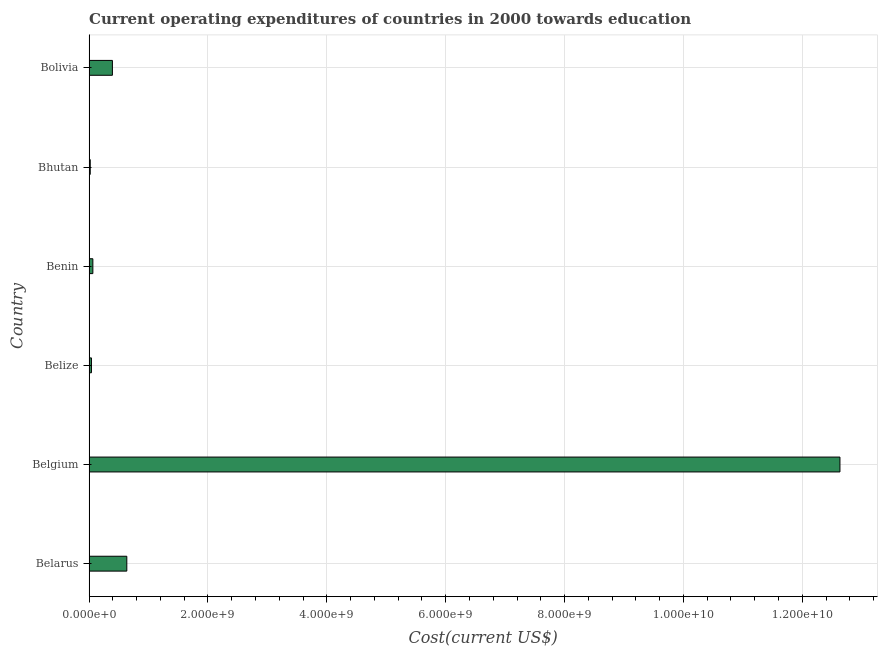What is the title of the graph?
Provide a short and direct response. Current operating expenditures of countries in 2000 towards education. What is the label or title of the X-axis?
Provide a succinct answer. Cost(current US$). What is the label or title of the Y-axis?
Make the answer very short. Country. What is the education expenditure in Belize?
Make the answer very short. 3.97e+07. Across all countries, what is the maximum education expenditure?
Provide a succinct answer. 1.26e+1. Across all countries, what is the minimum education expenditure?
Make the answer very short. 1.93e+07. In which country was the education expenditure minimum?
Make the answer very short. Bhutan. What is the sum of the education expenditure?
Ensure brevity in your answer.  1.38e+1. What is the difference between the education expenditure in Belize and Benin?
Give a very brief answer. -2.36e+07. What is the average education expenditure per country?
Offer a very short reply. 2.30e+09. What is the median education expenditure?
Give a very brief answer. 2.28e+08. What is the ratio of the education expenditure in Belarus to that in Belgium?
Ensure brevity in your answer.  0.05. What is the difference between the highest and the second highest education expenditure?
Provide a short and direct response. 1.20e+1. What is the difference between the highest and the lowest education expenditure?
Make the answer very short. 1.26e+1. What is the difference between two consecutive major ticks on the X-axis?
Your response must be concise. 2.00e+09. Are the values on the major ticks of X-axis written in scientific E-notation?
Your answer should be compact. Yes. What is the Cost(current US$) of Belarus?
Your answer should be compact. 6.35e+08. What is the Cost(current US$) in Belgium?
Ensure brevity in your answer.  1.26e+1. What is the Cost(current US$) in Belize?
Your response must be concise. 3.97e+07. What is the Cost(current US$) in Benin?
Keep it short and to the point. 6.34e+07. What is the Cost(current US$) of Bhutan?
Provide a succinct answer. 1.93e+07. What is the Cost(current US$) in Bolivia?
Offer a terse response. 3.92e+08. What is the difference between the Cost(current US$) in Belarus and Belgium?
Ensure brevity in your answer.  -1.20e+1. What is the difference between the Cost(current US$) in Belarus and Belize?
Your response must be concise. 5.95e+08. What is the difference between the Cost(current US$) in Belarus and Benin?
Offer a very short reply. 5.71e+08. What is the difference between the Cost(current US$) in Belarus and Bhutan?
Offer a terse response. 6.15e+08. What is the difference between the Cost(current US$) in Belarus and Bolivia?
Keep it short and to the point. 2.42e+08. What is the difference between the Cost(current US$) in Belgium and Belize?
Ensure brevity in your answer.  1.26e+1. What is the difference between the Cost(current US$) in Belgium and Benin?
Offer a terse response. 1.26e+1. What is the difference between the Cost(current US$) in Belgium and Bhutan?
Offer a very short reply. 1.26e+1. What is the difference between the Cost(current US$) in Belgium and Bolivia?
Keep it short and to the point. 1.22e+1. What is the difference between the Cost(current US$) in Belize and Benin?
Keep it short and to the point. -2.36e+07. What is the difference between the Cost(current US$) in Belize and Bhutan?
Make the answer very short. 2.04e+07. What is the difference between the Cost(current US$) in Belize and Bolivia?
Your answer should be compact. -3.53e+08. What is the difference between the Cost(current US$) in Benin and Bhutan?
Give a very brief answer. 4.41e+07. What is the difference between the Cost(current US$) in Benin and Bolivia?
Provide a succinct answer. -3.29e+08. What is the difference between the Cost(current US$) in Bhutan and Bolivia?
Give a very brief answer. -3.73e+08. What is the ratio of the Cost(current US$) in Belarus to that in Belgium?
Your response must be concise. 0.05. What is the ratio of the Cost(current US$) in Belarus to that in Belize?
Give a very brief answer. 15.97. What is the ratio of the Cost(current US$) in Belarus to that in Benin?
Keep it short and to the point. 10.01. What is the ratio of the Cost(current US$) in Belarus to that in Bhutan?
Ensure brevity in your answer.  32.87. What is the ratio of the Cost(current US$) in Belarus to that in Bolivia?
Your answer should be compact. 1.62. What is the ratio of the Cost(current US$) in Belgium to that in Belize?
Offer a terse response. 318.05. What is the ratio of the Cost(current US$) in Belgium to that in Benin?
Give a very brief answer. 199.38. What is the ratio of the Cost(current US$) in Belgium to that in Bhutan?
Make the answer very short. 654.53. What is the ratio of the Cost(current US$) in Belgium to that in Bolivia?
Provide a short and direct response. 32.2. What is the ratio of the Cost(current US$) in Belize to that in Benin?
Offer a very short reply. 0.63. What is the ratio of the Cost(current US$) in Belize to that in Bhutan?
Your response must be concise. 2.06. What is the ratio of the Cost(current US$) in Belize to that in Bolivia?
Keep it short and to the point. 0.1. What is the ratio of the Cost(current US$) in Benin to that in Bhutan?
Give a very brief answer. 3.28. What is the ratio of the Cost(current US$) in Benin to that in Bolivia?
Make the answer very short. 0.16. What is the ratio of the Cost(current US$) in Bhutan to that in Bolivia?
Provide a short and direct response. 0.05. 